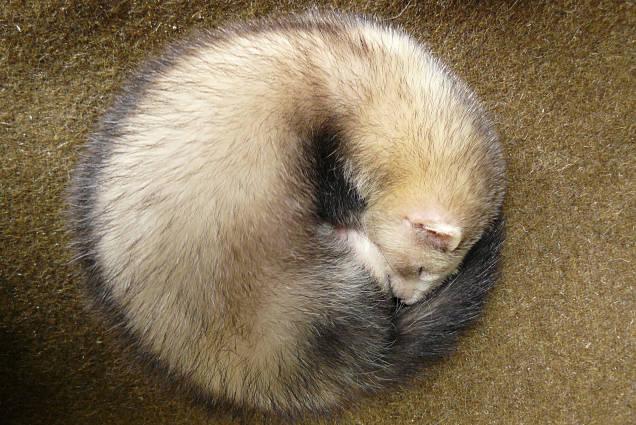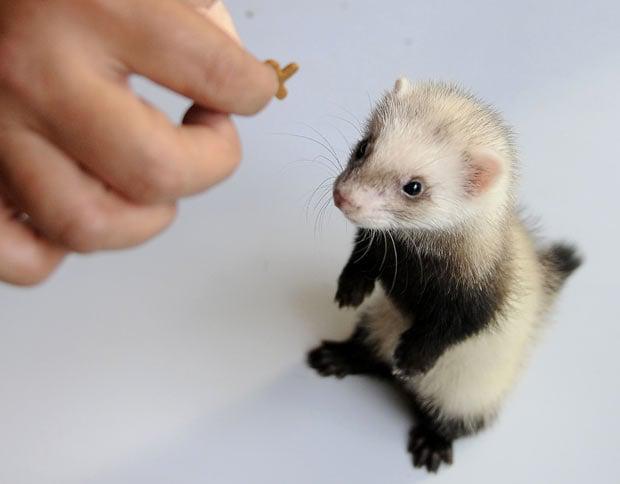The first image is the image on the left, the second image is the image on the right. Evaluate the accuracy of this statement regarding the images: "The right image depicts more ferrets than the left image.". Is it true? Answer yes or no. No. 